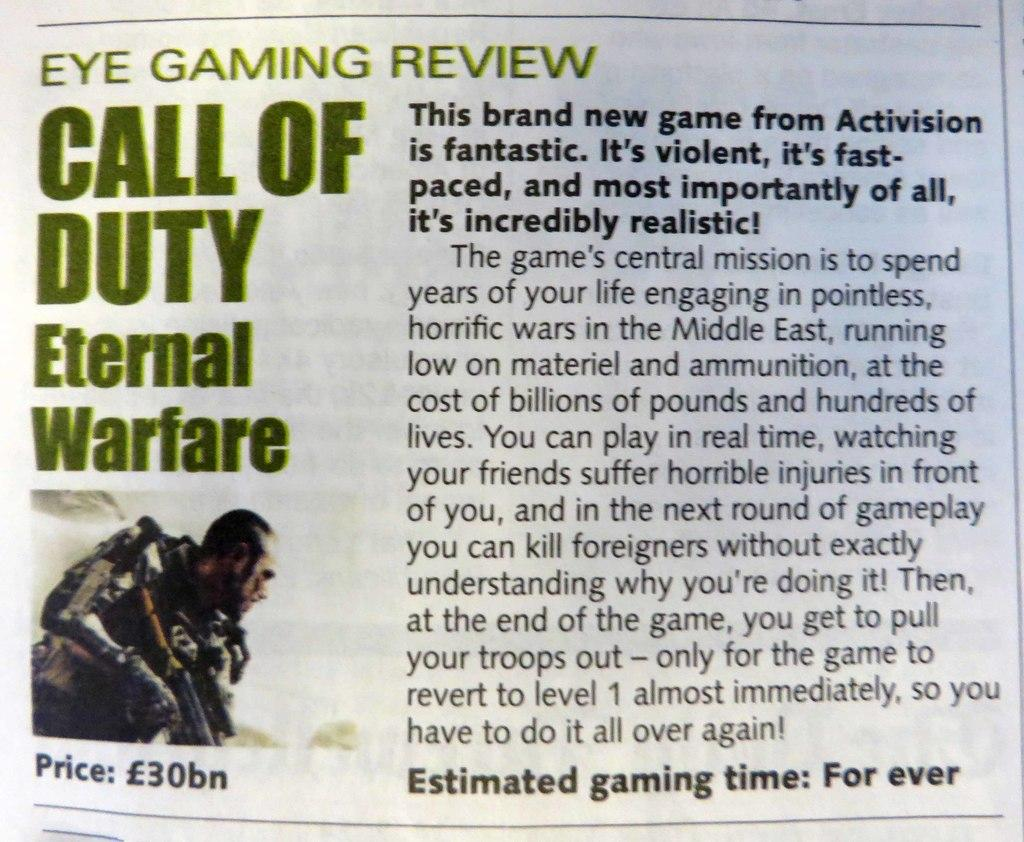Provide a one-sentence caption for the provided image. A game review for Call of Duty Eternal Warfare. 